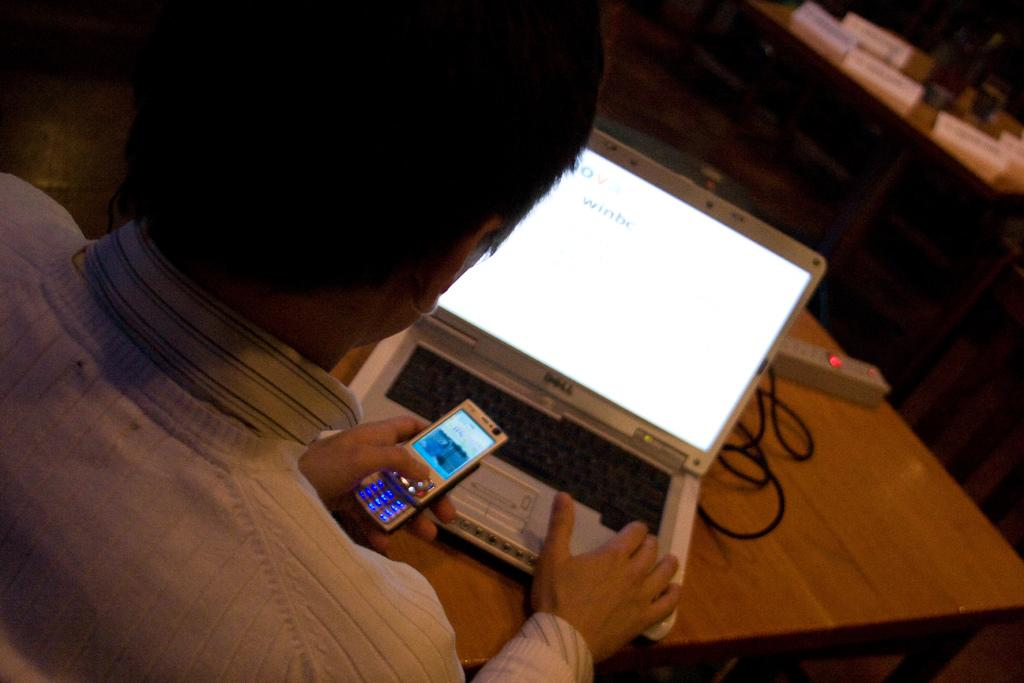<image>
Render a clear and concise summary of the photo. A man types something into a Dell product while holding his cell phone. 